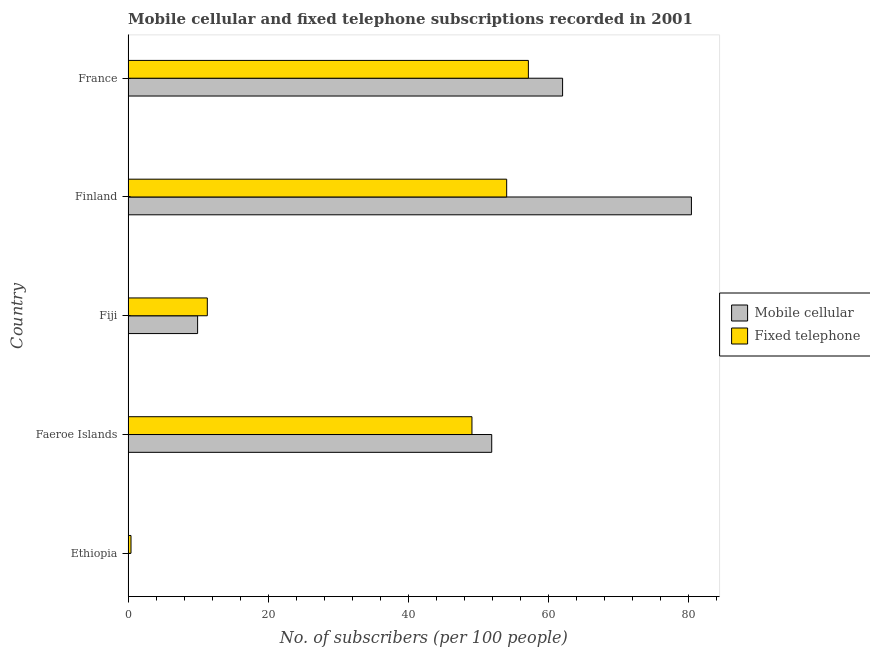Are the number of bars per tick equal to the number of legend labels?
Provide a short and direct response. Yes. What is the label of the 3rd group of bars from the top?
Make the answer very short. Fiji. In how many cases, is the number of bars for a given country not equal to the number of legend labels?
Ensure brevity in your answer.  0. What is the number of mobile cellular subscribers in France?
Ensure brevity in your answer.  62.08. Across all countries, what is the maximum number of mobile cellular subscribers?
Provide a short and direct response. 80.48. Across all countries, what is the minimum number of mobile cellular subscribers?
Provide a short and direct response. 0.04. In which country was the number of fixed telephone subscribers minimum?
Provide a succinct answer. Ethiopia. What is the total number of mobile cellular subscribers in the graph?
Provide a short and direct response. 204.48. What is the difference between the number of fixed telephone subscribers in Ethiopia and that in Faeroe Islands?
Make the answer very short. -48.71. What is the difference between the number of mobile cellular subscribers in Fiji and the number of fixed telephone subscribers in France?
Keep it short and to the point. -47.25. What is the average number of fixed telephone subscribers per country?
Provide a short and direct response. 34.43. What is the difference between the number of fixed telephone subscribers and number of mobile cellular subscribers in Faeroe Islands?
Offer a very short reply. -2.82. What is the ratio of the number of mobile cellular subscribers in Finland to that in France?
Your answer should be very brief. 1.3. Is the number of fixed telephone subscribers in Ethiopia less than that in Faeroe Islands?
Your answer should be very brief. Yes. What is the difference between the highest and the second highest number of mobile cellular subscribers?
Offer a terse response. 18.41. What is the difference between the highest and the lowest number of mobile cellular subscribers?
Offer a very short reply. 80.44. What does the 1st bar from the top in Faeroe Islands represents?
Your response must be concise. Fixed telephone. What does the 2nd bar from the bottom in Ethiopia represents?
Your response must be concise. Fixed telephone. How many bars are there?
Ensure brevity in your answer.  10. What is the difference between two consecutive major ticks on the X-axis?
Your response must be concise. 20. Are the values on the major ticks of X-axis written in scientific E-notation?
Your answer should be compact. No. Does the graph contain any zero values?
Your response must be concise. No. How many legend labels are there?
Provide a succinct answer. 2. What is the title of the graph?
Give a very brief answer. Mobile cellular and fixed telephone subscriptions recorded in 2001. What is the label or title of the X-axis?
Your answer should be very brief. No. of subscribers (per 100 people). What is the label or title of the Y-axis?
Ensure brevity in your answer.  Country. What is the No. of subscribers (per 100 people) of Mobile cellular in Ethiopia?
Provide a short and direct response. 0.04. What is the No. of subscribers (per 100 people) in Fixed telephone in Ethiopia?
Keep it short and to the point. 0.42. What is the No. of subscribers (per 100 people) of Mobile cellular in Faeroe Islands?
Your answer should be very brief. 51.95. What is the No. of subscribers (per 100 people) of Fixed telephone in Faeroe Islands?
Your answer should be compact. 49.13. What is the No. of subscribers (per 100 people) of Mobile cellular in Fiji?
Offer a very short reply. 9.93. What is the No. of subscribers (per 100 people) in Fixed telephone in Fiji?
Your answer should be very brief. 11.32. What is the No. of subscribers (per 100 people) in Mobile cellular in Finland?
Make the answer very short. 80.48. What is the No. of subscribers (per 100 people) of Fixed telephone in Finland?
Offer a very short reply. 54.09. What is the No. of subscribers (per 100 people) in Mobile cellular in France?
Your answer should be compact. 62.08. What is the No. of subscribers (per 100 people) in Fixed telephone in France?
Your answer should be very brief. 57.19. Across all countries, what is the maximum No. of subscribers (per 100 people) in Mobile cellular?
Offer a very short reply. 80.48. Across all countries, what is the maximum No. of subscribers (per 100 people) of Fixed telephone?
Make the answer very short. 57.19. Across all countries, what is the minimum No. of subscribers (per 100 people) of Mobile cellular?
Keep it short and to the point. 0.04. Across all countries, what is the minimum No. of subscribers (per 100 people) in Fixed telephone?
Offer a very short reply. 0.42. What is the total No. of subscribers (per 100 people) of Mobile cellular in the graph?
Your response must be concise. 204.48. What is the total No. of subscribers (per 100 people) of Fixed telephone in the graph?
Make the answer very short. 172.14. What is the difference between the No. of subscribers (per 100 people) of Mobile cellular in Ethiopia and that in Faeroe Islands?
Your answer should be very brief. -51.91. What is the difference between the No. of subscribers (per 100 people) of Fixed telephone in Ethiopia and that in Faeroe Islands?
Your response must be concise. -48.71. What is the difference between the No. of subscribers (per 100 people) in Mobile cellular in Ethiopia and that in Fiji?
Offer a terse response. -9.89. What is the difference between the No. of subscribers (per 100 people) in Fixed telephone in Ethiopia and that in Fiji?
Your answer should be very brief. -10.9. What is the difference between the No. of subscribers (per 100 people) of Mobile cellular in Ethiopia and that in Finland?
Keep it short and to the point. -80.44. What is the difference between the No. of subscribers (per 100 people) in Fixed telephone in Ethiopia and that in Finland?
Give a very brief answer. -53.67. What is the difference between the No. of subscribers (per 100 people) in Mobile cellular in Ethiopia and that in France?
Make the answer very short. -62.03. What is the difference between the No. of subscribers (per 100 people) in Fixed telephone in Ethiopia and that in France?
Your answer should be very brief. -56.77. What is the difference between the No. of subscribers (per 100 people) of Mobile cellular in Faeroe Islands and that in Fiji?
Provide a short and direct response. 42.02. What is the difference between the No. of subscribers (per 100 people) in Fixed telephone in Faeroe Islands and that in Fiji?
Provide a succinct answer. 37.81. What is the difference between the No. of subscribers (per 100 people) in Mobile cellular in Faeroe Islands and that in Finland?
Make the answer very short. -28.53. What is the difference between the No. of subscribers (per 100 people) in Fixed telephone in Faeroe Islands and that in Finland?
Ensure brevity in your answer.  -4.96. What is the difference between the No. of subscribers (per 100 people) in Mobile cellular in Faeroe Islands and that in France?
Ensure brevity in your answer.  -10.12. What is the difference between the No. of subscribers (per 100 people) of Fixed telephone in Faeroe Islands and that in France?
Offer a terse response. -8.06. What is the difference between the No. of subscribers (per 100 people) of Mobile cellular in Fiji and that in Finland?
Make the answer very short. -70.55. What is the difference between the No. of subscribers (per 100 people) of Fixed telephone in Fiji and that in Finland?
Your answer should be compact. -42.77. What is the difference between the No. of subscribers (per 100 people) in Mobile cellular in Fiji and that in France?
Provide a succinct answer. -52.14. What is the difference between the No. of subscribers (per 100 people) of Fixed telephone in Fiji and that in France?
Offer a terse response. -45.87. What is the difference between the No. of subscribers (per 100 people) in Mobile cellular in Finland and that in France?
Make the answer very short. 18.4. What is the difference between the No. of subscribers (per 100 people) in Fixed telephone in Finland and that in France?
Your answer should be very brief. -3.1. What is the difference between the No. of subscribers (per 100 people) in Mobile cellular in Ethiopia and the No. of subscribers (per 100 people) in Fixed telephone in Faeroe Islands?
Make the answer very short. -49.09. What is the difference between the No. of subscribers (per 100 people) in Mobile cellular in Ethiopia and the No. of subscribers (per 100 people) in Fixed telephone in Fiji?
Ensure brevity in your answer.  -11.28. What is the difference between the No. of subscribers (per 100 people) in Mobile cellular in Ethiopia and the No. of subscribers (per 100 people) in Fixed telephone in Finland?
Keep it short and to the point. -54.05. What is the difference between the No. of subscribers (per 100 people) of Mobile cellular in Ethiopia and the No. of subscribers (per 100 people) of Fixed telephone in France?
Ensure brevity in your answer.  -57.15. What is the difference between the No. of subscribers (per 100 people) of Mobile cellular in Faeroe Islands and the No. of subscribers (per 100 people) of Fixed telephone in Fiji?
Your response must be concise. 40.63. What is the difference between the No. of subscribers (per 100 people) of Mobile cellular in Faeroe Islands and the No. of subscribers (per 100 people) of Fixed telephone in Finland?
Ensure brevity in your answer.  -2.14. What is the difference between the No. of subscribers (per 100 people) in Mobile cellular in Faeroe Islands and the No. of subscribers (per 100 people) in Fixed telephone in France?
Give a very brief answer. -5.24. What is the difference between the No. of subscribers (per 100 people) in Mobile cellular in Fiji and the No. of subscribers (per 100 people) in Fixed telephone in Finland?
Your answer should be compact. -44.15. What is the difference between the No. of subscribers (per 100 people) in Mobile cellular in Fiji and the No. of subscribers (per 100 people) in Fixed telephone in France?
Give a very brief answer. -47.25. What is the difference between the No. of subscribers (per 100 people) of Mobile cellular in Finland and the No. of subscribers (per 100 people) of Fixed telephone in France?
Make the answer very short. 23.29. What is the average No. of subscribers (per 100 people) of Mobile cellular per country?
Your answer should be very brief. 40.9. What is the average No. of subscribers (per 100 people) in Fixed telephone per country?
Your response must be concise. 34.43. What is the difference between the No. of subscribers (per 100 people) of Mobile cellular and No. of subscribers (per 100 people) of Fixed telephone in Ethiopia?
Keep it short and to the point. -0.38. What is the difference between the No. of subscribers (per 100 people) of Mobile cellular and No. of subscribers (per 100 people) of Fixed telephone in Faeroe Islands?
Make the answer very short. 2.82. What is the difference between the No. of subscribers (per 100 people) of Mobile cellular and No. of subscribers (per 100 people) of Fixed telephone in Fiji?
Give a very brief answer. -1.39. What is the difference between the No. of subscribers (per 100 people) in Mobile cellular and No. of subscribers (per 100 people) in Fixed telephone in Finland?
Make the answer very short. 26.39. What is the difference between the No. of subscribers (per 100 people) of Mobile cellular and No. of subscribers (per 100 people) of Fixed telephone in France?
Your answer should be compact. 4.89. What is the ratio of the No. of subscribers (per 100 people) of Mobile cellular in Ethiopia to that in Faeroe Islands?
Keep it short and to the point. 0. What is the ratio of the No. of subscribers (per 100 people) in Fixed telephone in Ethiopia to that in Faeroe Islands?
Make the answer very short. 0.01. What is the ratio of the No. of subscribers (per 100 people) of Mobile cellular in Ethiopia to that in Fiji?
Give a very brief answer. 0. What is the ratio of the No. of subscribers (per 100 people) of Fixed telephone in Ethiopia to that in Fiji?
Your response must be concise. 0.04. What is the ratio of the No. of subscribers (per 100 people) in Fixed telephone in Ethiopia to that in Finland?
Offer a very short reply. 0.01. What is the ratio of the No. of subscribers (per 100 people) of Mobile cellular in Ethiopia to that in France?
Make the answer very short. 0. What is the ratio of the No. of subscribers (per 100 people) in Fixed telephone in Ethiopia to that in France?
Provide a succinct answer. 0.01. What is the ratio of the No. of subscribers (per 100 people) in Mobile cellular in Faeroe Islands to that in Fiji?
Your answer should be compact. 5.23. What is the ratio of the No. of subscribers (per 100 people) of Fixed telephone in Faeroe Islands to that in Fiji?
Ensure brevity in your answer.  4.34. What is the ratio of the No. of subscribers (per 100 people) in Mobile cellular in Faeroe Islands to that in Finland?
Offer a very short reply. 0.65. What is the ratio of the No. of subscribers (per 100 people) in Fixed telephone in Faeroe Islands to that in Finland?
Ensure brevity in your answer.  0.91. What is the ratio of the No. of subscribers (per 100 people) of Mobile cellular in Faeroe Islands to that in France?
Your answer should be compact. 0.84. What is the ratio of the No. of subscribers (per 100 people) of Fixed telephone in Faeroe Islands to that in France?
Provide a short and direct response. 0.86. What is the ratio of the No. of subscribers (per 100 people) in Mobile cellular in Fiji to that in Finland?
Offer a terse response. 0.12. What is the ratio of the No. of subscribers (per 100 people) of Fixed telephone in Fiji to that in Finland?
Offer a very short reply. 0.21. What is the ratio of the No. of subscribers (per 100 people) of Mobile cellular in Fiji to that in France?
Provide a short and direct response. 0.16. What is the ratio of the No. of subscribers (per 100 people) of Fixed telephone in Fiji to that in France?
Provide a succinct answer. 0.2. What is the ratio of the No. of subscribers (per 100 people) in Mobile cellular in Finland to that in France?
Offer a very short reply. 1.3. What is the ratio of the No. of subscribers (per 100 people) of Fixed telephone in Finland to that in France?
Keep it short and to the point. 0.95. What is the difference between the highest and the second highest No. of subscribers (per 100 people) in Mobile cellular?
Provide a succinct answer. 18.4. What is the difference between the highest and the second highest No. of subscribers (per 100 people) of Fixed telephone?
Ensure brevity in your answer.  3.1. What is the difference between the highest and the lowest No. of subscribers (per 100 people) in Mobile cellular?
Make the answer very short. 80.44. What is the difference between the highest and the lowest No. of subscribers (per 100 people) of Fixed telephone?
Your response must be concise. 56.77. 